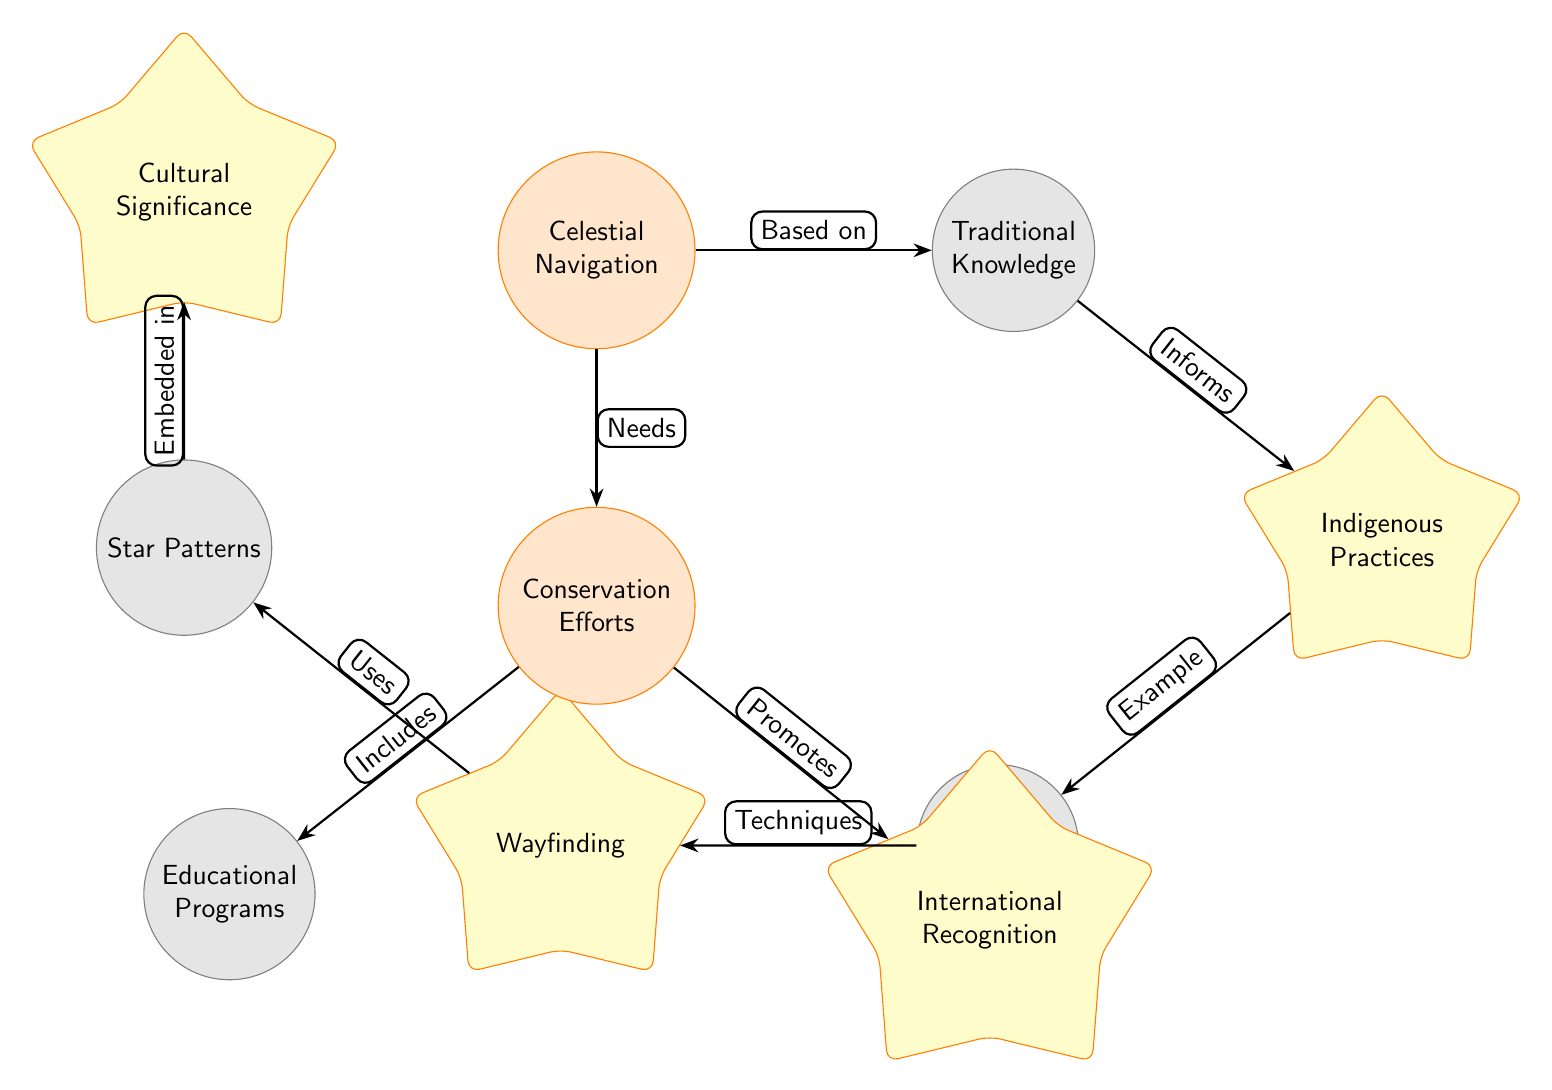What is the primary focus of the diagram? The primary focus of the diagram is indicated by the central node, which is "Celestial Navigation." This node represents the overarching concept that connects various related elements such as Traditional Knowledge and Conservation Efforts in the context of navigation.
Answer: Celestial Navigation How many main nodes are present in the diagram? The diagram comprises a total of 8 main nodes, which include Celestial Navigation, Traditional Knowledge, Indigenous Practices, Polynesian Navigation, Wayfinding, Star Patterns, Conservation Efforts, Educational Programs, and International Recognition. Counting these nodes gives us the total.
Answer: 8 Which node is associated with "Based on"? The edge labeled "Based on" connects the node "Celestial Navigation" to "Traditional Knowledge." This document shows the foundational relationship between these two concepts, where Traditional Knowledge serves as a basis for Celestial Navigation practices.
Answer: Traditional Knowledge What relationship is indicated between "Conservation Efforts" and "International Recognition"? The direction of the edge from "Conservation Efforts" to "International Recognition" indicates a promoting relationship. This means that Conservation Efforts play a role in promoting International Recognition, showcasing how efforts in conservation can lead to broader acknowledgment on a global scale.
Answer: Promotes What informs "Indigenous Practices"? The node "Traditional Knowledge" directly informs "Indigenous Practices," as illustrated by the edge labeled "Informs." This suggests that Indigenous Practices are shaped and guided by the underlying framework of Traditional Knowledge.
Answer: Traditional Knowledge Which node is described as an example of Indigenous Practices? The edge labeled "Example" connects "Indigenous Practices" to "Polynesian Navigation." This indicates that Polynesian Navigation serves as a specific instance or illustration of the broader category of Indigenous Practices.
Answer: Polynesian Navigation What is embedded in "Star Patterns"? The edge indicates that "Cultural Significance" is embedded in "Star Patterns." This relationship suggests that the understanding and recognition of Star Patterns within navigation carry inherent cultural meanings and importance.
Answer: Cultural Significance What includes "Educational Programs"? The node "Conservation Efforts" is shown to include "Educational Programs," highlighting how conservation initiatives often incorporate educational activities aimed at raising awareness and promoting understanding of celestial navigation and traditional practices.
Answer: Educational Programs How does "Wayfinding" relate to "Star Patterns"? The relationship described by the edge labeled "Uses" shows that "Wayfinding" utilizes "Star Patterns." This indicates that Star Patterns are a practical tool within the practice of Wayfinding, essential for navigation and orientation.
Answer: Uses 